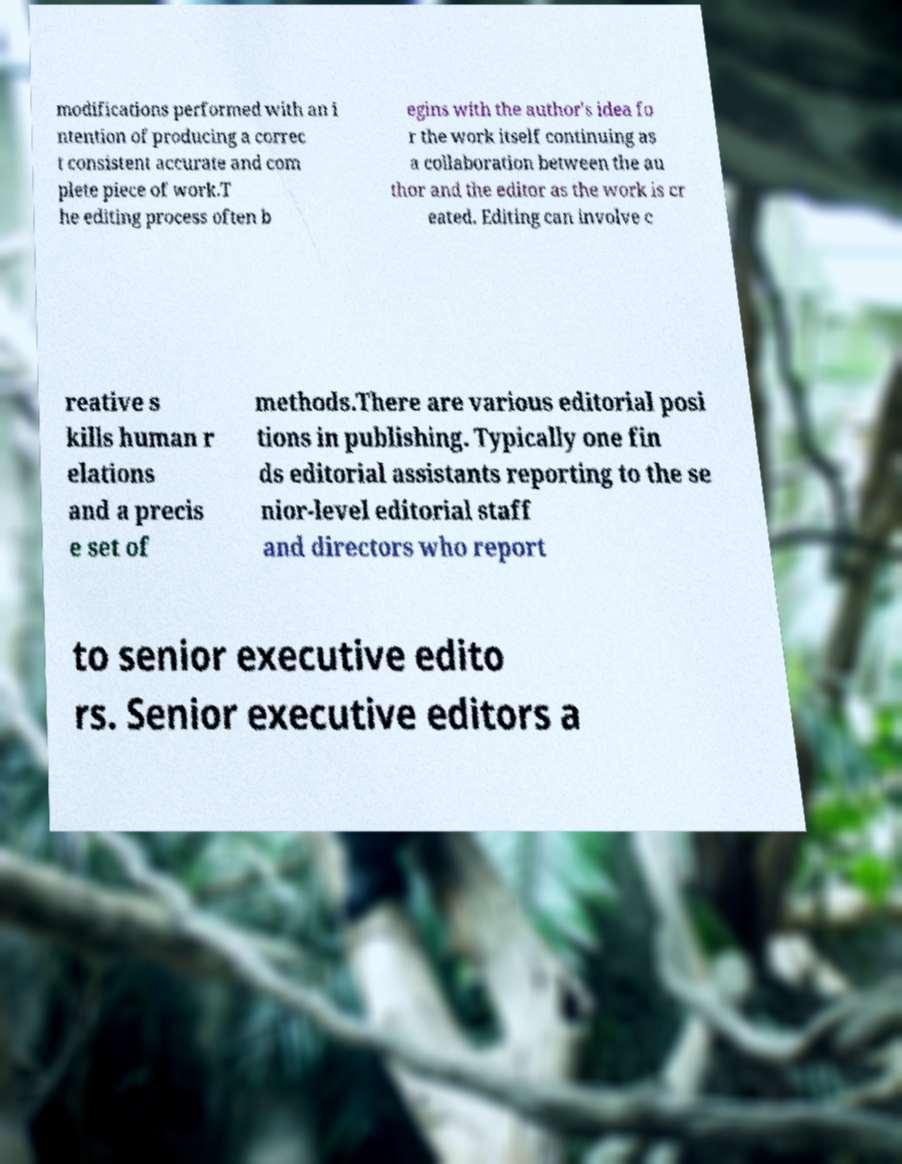Can you read and provide the text displayed in the image?This photo seems to have some interesting text. Can you extract and type it out for me? modifications performed with an i ntention of producing a correc t consistent accurate and com plete piece of work.T he editing process often b egins with the author's idea fo r the work itself continuing as a collaboration between the au thor and the editor as the work is cr eated. Editing can involve c reative s kills human r elations and a precis e set of methods.There are various editorial posi tions in publishing. Typically one fin ds editorial assistants reporting to the se nior-level editorial staff and directors who report to senior executive edito rs. Senior executive editors a 